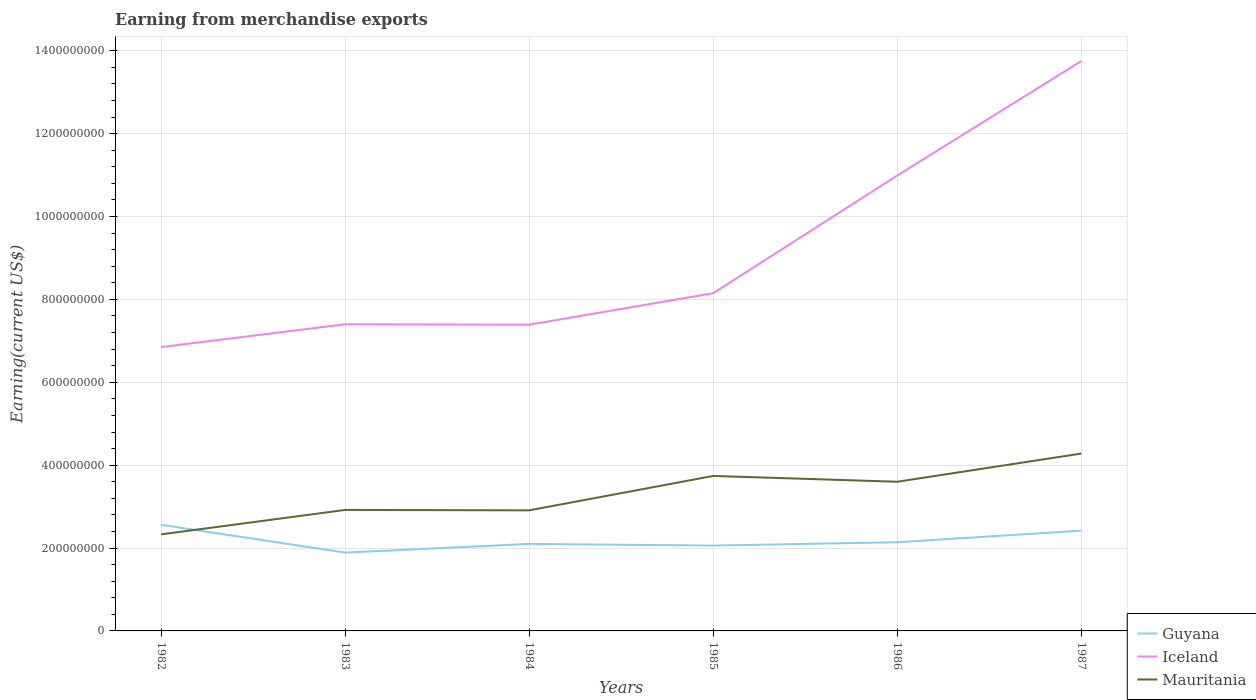Does the line corresponding to Mauritania intersect with the line corresponding to Guyana?
Your response must be concise. Yes. Is the number of lines equal to the number of legend labels?
Your response must be concise. Yes. Across all years, what is the maximum amount earned from merchandise exports in Guyana?
Your answer should be compact. 1.89e+08. In which year was the amount earned from merchandise exports in Iceland maximum?
Offer a terse response. 1982. What is the total amount earned from merchandise exports in Guyana in the graph?
Provide a short and direct response. -4.00e+06. What is the difference between the highest and the second highest amount earned from merchandise exports in Guyana?
Your response must be concise. 6.70e+07. What is the difference between the highest and the lowest amount earned from merchandise exports in Mauritania?
Your answer should be very brief. 3. How many lines are there?
Your response must be concise. 3. How many years are there in the graph?
Your answer should be very brief. 6. Are the values on the major ticks of Y-axis written in scientific E-notation?
Your answer should be compact. No. Does the graph contain any zero values?
Provide a short and direct response. No. Does the graph contain grids?
Offer a terse response. Yes. Where does the legend appear in the graph?
Give a very brief answer. Bottom right. What is the title of the graph?
Provide a succinct answer. Earning from merchandise exports. What is the label or title of the X-axis?
Give a very brief answer. Years. What is the label or title of the Y-axis?
Provide a short and direct response. Earning(current US$). What is the Earning(current US$) of Guyana in 1982?
Offer a terse response. 2.56e+08. What is the Earning(current US$) in Iceland in 1982?
Offer a very short reply. 6.85e+08. What is the Earning(current US$) in Mauritania in 1982?
Your answer should be compact. 2.33e+08. What is the Earning(current US$) in Guyana in 1983?
Keep it short and to the point. 1.89e+08. What is the Earning(current US$) of Iceland in 1983?
Ensure brevity in your answer.  7.40e+08. What is the Earning(current US$) in Mauritania in 1983?
Ensure brevity in your answer.  2.92e+08. What is the Earning(current US$) of Guyana in 1984?
Offer a terse response. 2.10e+08. What is the Earning(current US$) in Iceland in 1984?
Provide a succinct answer. 7.39e+08. What is the Earning(current US$) of Mauritania in 1984?
Offer a terse response. 2.91e+08. What is the Earning(current US$) in Guyana in 1985?
Offer a terse response. 2.06e+08. What is the Earning(current US$) in Iceland in 1985?
Provide a short and direct response. 8.15e+08. What is the Earning(current US$) in Mauritania in 1985?
Offer a terse response. 3.74e+08. What is the Earning(current US$) of Guyana in 1986?
Your response must be concise. 2.14e+08. What is the Earning(current US$) of Iceland in 1986?
Provide a succinct answer. 1.10e+09. What is the Earning(current US$) in Mauritania in 1986?
Provide a short and direct response. 3.60e+08. What is the Earning(current US$) in Guyana in 1987?
Offer a very short reply. 2.42e+08. What is the Earning(current US$) in Iceland in 1987?
Offer a very short reply. 1.38e+09. What is the Earning(current US$) in Mauritania in 1987?
Make the answer very short. 4.28e+08. Across all years, what is the maximum Earning(current US$) in Guyana?
Your response must be concise. 2.56e+08. Across all years, what is the maximum Earning(current US$) of Iceland?
Keep it short and to the point. 1.38e+09. Across all years, what is the maximum Earning(current US$) of Mauritania?
Your response must be concise. 4.28e+08. Across all years, what is the minimum Earning(current US$) of Guyana?
Offer a terse response. 1.89e+08. Across all years, what is the minimum Earning(current US$) of Iceland?
Make the answer very short. 6.85e+08. Across all years, what is the minimum Earning(current US$) in Mauritania?
Keep it short and to the point. 2.33e+08. What is the total Earning(current US$) in Guyana in the graph?
Ensure brevity in your answer.  1.32e+09. What is the total Earning(current US$) of Iceland in the graph?
Your answer should be very brief. 5.45e+09. What is the total Earning(current US$) of Mauritania in the graph?
Your answer should be very brief. 1.98e+09. What is the difference between the Earning(current US$) in Guyana in 1982 and that in 1983?
Your answer should be compact. 6.70e+07. What is the difference between the Earning(current US$) of Iceland in 1982 and that in 1983?
Make the answer very short. -5.50e+07. What is the difference between the Earning(current US$) of Mauritania in 1982 and that in 1983?
Offer a very short reply. -5.90e+07. What is the difference between the Earning(current US$) in Guyana in 1982 and that in 1984?
Provide a short and direct response. 4.60e+07. What is the difference between the Earning(current US$) in Iceland in 1982 and that in 1984?
Provide a short and direct response. -5.40e+07. What is the difference between the Earning(current US$) in Mauritania in 1982 and that in 1984?
Your response must be concise. -5.80e+07. What is the difference between the Earning(current US$) in Iceland in 1982 and that in 1985?
Offer a very short reply. -1.30e+08. What is the difference between the Earning(current US$) in Mauritania in 1982 and that in 1985?
Make the answer very short. -1.41e+08. What is the difference between the Earning(current US$) of Guyana in 1982 and that in 1986?
Give a very brief answer. 4.20e+07. What is the difference between the Earning(current US$) of Iceland in 1982 and that in 1986?
Make the answer very short. -4.14e+08. What is the difference between the Earning(current US$) in Mauritania in 1982 and that in 1986?
Your answer should be very brief. -1.27e+08. What is the difference between the Earning(current US$) in Guyana in 1982 and that in 1987?
Give a very brief answer. 1.40e+07. What is the difference between the Earning(current US$) in Iceland in 1982 and that in 1987?
Give a very brief answer. -6.90e+08. What is the difference between the Earning(current US$) in Mauritania in 1982 and that in 1987?
Ensure brevity in your answer.  -1.95e+08. What is the difference between the Earning(current US$) of Guyana in 1983 and that in 1984?
Your answer should be very brief. -2.10e+07. What is the difference between the Earning(current US$) of Mauritania in 1983 and that in 1984?
Make the answer very short. 1.00e+06. What is the difference between the Earning(current US$) in Guyana in 1983 and that in 1985?
Keep it short and to the point. -1.70e+07. What is the difference between the Earning(current US$) of Iceland in 1983 and that in 1985?
Your answer should be very brief. -7.50e+07. What is the difference between the Earning(current US$) of Mauritania in 1983 and that in 1985?
Your answer should be compact. -8.20e+07. What is the difference between the Earning(current US$) in Guyana in 1983 and that in 1986?
Offer a very short reply. -2.50e+07. What is the difference between the Earning(current US$) of Iceland in 1983 and that in 1986?
Make the answer very short. -3.59e+08. What is the difference between the Earning(current US$) of Mauritania in 1983 and that in 1986?
Your answer should be compact. -6.80e+07. What is the difference between the Earning(current US$) of Guyana in 1983 and that in 1987?
Your response must be concise. -5.30e+07. What is the difference between the Earning(current US$) in Iceland in 1983 and that in 1987?
Your answer should be compact. -6.35e+08. What is the difference between the Earning(current US$) in Mauritania in 1983 and that in 1987?
Offer a terse response. -1.36e+08. What is the difference between the Earning(current US$) of Iceland in 1984 and that in 1985?
Offer a terse response. -7.60e+07. What is the difference between the Earning(current US$) of Mauritania in 1984 and that in 1985?
Your answer should be compact. -8.30e+07. What is the difference between the Earning(current US$) in Iceland in 1984 and that in 1986?
Provide a succinct answer. -3.60e+08. What is the difference between the Earning(current US$) in Mauritania in 1984 and that in 1986?
Keep it short and to the point. -6.90e+07. What is the difference between the Earning(current US$) of Guyana in 1984 and that in 1987?
Your answer should be compact. -3.20e+07. What is the difference between the Earning(current US$) of Iceland in 1984 and that in 1987?
Make the answer very short. -6.36e+08. What is the difference between the Earning(current US$) of Mauritania in 1984 and that in 1987?
Your answer should be very brief. -1.37e+08. What is the difference between the Earning(current US$) in Guyana in 1985 and that in 1986?
Provide a succinct answer. -8.00e+06. What is the difference between the Earning(current US$) of Iceland in 1985 and that in 1986?
Your answer should be very brief. -2.84e+08. What is the difference between the Earning(current US$) in Mauritania in 1985 and that in 1986?
Keep it short and to the point. 1.40e+07. What is the difference between the Earning(current US$) of Guyana in 1985 and that in 1987?
Offer a very short reply. -3.60e+07. What is the difference between the Earning(current US$) in Iceland in 1985 and that in 1987?
Give a very brief answer. -5.60e+08. What is the difference between the Earning(current US$) of Mauritania in 1985 and that in 1987?
Your answer should be very brief. -5.40e+07. What is the difference between the Earning(current US$) of Guyana in 1986 and that in 1987?
Keep it short and to the point. -2.80e+07. What is the difference between the Earning(current US$) of Iceland in 1986 and that in 1987?
Give a very brief answer. -2.76e+08. What is the difference between the Earning(current US$) in Mauritania in 1986 and that in 1987?
Ensure brevity in your answer.  -6.80e+07. What is the difference between the Earning(current US$) of Guyana in 1982 and the Earning(current US$) of Iceland in 1983?
Keep it short and to the point. -4.84e+08. What is the difference between the Earning(current US$) in Guyana in 1982 and the Earning(current US$) in Mauritania in 1983?
Make the answer very short. -3.60e+07. What is the difference between the Earning(current US$) in Iceland in 1982 and the Earning(current US$) in Mauritania in 1983?
Give a very brief answer. 3.93e+08. What is the difference between the Earning(current US$) in Guyana in 1982 and the Earning(current US$) in Iceland in 1984?
Your answer should be very brief. -4.83e+08. What is the difference between the Earning(current US$) of Guyana in 1982 and the Earning(current US$) of Mauritania in 1984?
Keep it short and to the point. -3.50e+07. What is the difference between the Earning(current US$) in Iceland in 1982 and the Earning(current US$) in Mauritania in 1984?
Your response must be concise. 3.94e+08. What is the difference between the Earning(current US$) in Guyana in 1982 and the Earning(current US$) in Iceland in 1985?
Keep it short and to the point. -5.59e+08. What is the difference between the Earning(current US$) in Guyana in 1982 and the Earning(current US$) in Mauritania in 1985?
Make the answer very short. -1.18e+08. What is the difference between the Earning(current US$) in Iceland in 1982 and the Earning(current US$) in Mauritania in 1985?
Keep it short and to the point. 3.11e+08. What is the difference between the Earning(current US$) in Guyana in 1982 and the Earning(current US$) in Iceland in 1986?
Provide a short and direct response. -8.43e+08. What is the difference between the Earning(current US$) of Guyana in 1982 and the Earning(current US$) of Mauritania in 1986?
Make the answer very short. -1.04e+08. What is the difference between the Earning(current US$) in Iceland in 1982 and the Earning(current US$) in Mauritania in 1986?
Give a very brief answer. 3.25e+08. What is the difference between the Earning(current US$) of Guyana in 1982 and the Earning(current US$) of Iceland in 1987?
Provide a succinct answer. -1.12e+09. What is the difference between the Earning(current US$) in Guyana in 1982 and the Earning(current US$) in Mauritania in 1987?
Your response must be concise. -1.72e+08. What is the difference between the Earning(current US$) of Iceland in 1982 and the Earning(current US$) of Mauritania in 1987?
Your answer should be very brief. 2.57e+08. What is the difference between the Earning(current US$) in Guyana in 1983 and the Earning(current US$) in Iceland in 1984?
Offer a very short reply. -5.50e+08. What is the difference between the Earning(current US$) of Guyana in 1983 and the Earning(current US$) of Mauritania in 1984?
Your answer should be compact. -1.02e+08. What is the difference between the Earning(current US$) in Iceland in 1983 and the Earning(current US$) in Mauritania in 1984?
Provide a short and direct response. 4.49e+08. What is the difference between the Earning(current US$) of Guyana in 1983 and the Earning(current US$) of Iceland in 1985?
Provide a succinct answer. -6.26e+08. What is the difference between the Earning(current US$) of Guyana in 1983 and the Earning(current US$) of Mauritania in 1985?
Offer a very short reply. -1.85e+08. What is the difference between the Earning(current US$) in Iceland in 1983 and the Earning(current US$) in Mauritania in 1985?
Offer a terse response. 3.66e+08. What is the difference between the Earning(current US$) of Guyana in 1983 and the Earning(current US$) of Iceland in 1986?
Keep it short and to the point. -9.10e+08. What is the difference between the Earning(current US$) in Guyana in 1983 and the Earning(current US$) in Mauritania in 1986?
Your answer should be very brief. -1.71e+08. What is the difference between the Earning(current US$) of Iceland in 1983 and the Earning(current US$) of Mauritania in 1986?
Provide a succinct answer. 3.80e+08. What is the difference between the Earning(current US$) of Guyana in 1983 and the Earning(current US$) of Iceland in 1987?
Your answer should be very brief. -1.19e+09. What is the difference between the Earning(current US$) of Guyana in 1983 and the Earning(current US$) of Mauritania in 1987?
Your response must be concise. -2.39e+08. What is the difference between the Earning(current US$) of Iceland in 1983 and the Earning(current US$) of Mauritania in 1987?
Keep it short and to the point. 3.12e+08. What is the difference between the Earning(current US$) in Guyana in 1984 and the Earning(current US$) in Iceland in 1985?
Make the answer very short. -6.05e+08. What is the difference between the Earning(current US$) in Guyana in 1984 and the Earning(current US$) in Mauritania in 1985?
Give a very brief answer. -1.64e+08. What is the difference between the Earning(current US$) in Iceland in 1984 and the Earning(current US$) in Mauritania in 1985?
Offer a very short reply. 3.65e+08. What is the difference between the Earning(current US$) of Guyana in 1984 and the Earning(current US$) of Iceland in 1986?
Give a very brief answer. -8.89e+08. What is the difference between the Earning(current US$) in Guyana in 1984 and the Earning(current US$) in Mauritania in 1986?
Your answer should be compact. -1.50e+08. What is the difference between the Earning(current US$) of Iceland in 1984 and the Earning(current US$) of Mauritania in 1986?
Your answer should be very brief. 3.79e+08. What is the difference between the Earning(current US$) in Guyana in 1984 and the Earning(current US$) in Iceland in 1987?
Keep it short and to the point. -1.16e+09. What is the difference between the Earning(current US$) of Guyana in 1984 and the Earning(current US$) of Mauritania in 1987?
Ensure brevity in your answer.  -2.18e+08. What is the difference between the Earning(current US$) of Iceland in 1984 and the Earning(current US$) of Mauritania in 1987?
Offer a very short reply. 3.11e+08. What is the difference between the Earning(current US$) of Guyana in 1985 and the Earning(current US$) of Iceland in 1986?
Your response must be concise. -8.93e+08. What is the difference between the Earning(current US$) of Guyana in 1985 and the Earning(current US$) of Mauritania in 1986?
Offer a terse response. -1.54e+08. What is the difference between the Earning(current US$) in Iceland in 1985 and the Earning(current US$) in Mauritania in 1986?
Keep it short and to the point. 4.55e+08. What is the difference between the Earning(current US$) of Guyana in 1985 and the Earning(current US$) of Iceland in 1987?
Your answer should be very brief. -1.17e+09. What is the difference between the Earning(current US$) of Guyana in 1985 and the Earning(current US$) of Mauritania in 1987?
Your answer should be very brief. -2.22e+08. What is the difference between the Earning(current US$) of Iceland in 1985 and the Earning(current US$) of Mauritania in 1987?
Offer a very short reply. 3.87e+08. What is the difference between the Earning(current US$) of Guyana in 1986 and the Earning(current US$) of Iceland in 1987?
Make the answer very short. -1.16e+09. What is the difference between the Earning(current US$) in Guyana in 1986 and the Earning(current US$) in Mauritania in 1987?
Ensure brevity in your answer.  -2.14e+08. What is the difference between the Earning(current US$) of Iceland in 1986 and the Earning(current US$) of Mauritania in 1987?
Your response must be concise. 6.71e+08. What is the average Earning(current US$) in Guyana per year?
Provide a succinct answer. 2.20e+08. What is the average Earning(current US$) in Iceland per year?
Give a very brief answer. 9.09e+08. What is the average Earning(current US$) of Mauritania per year?
Your response must be concise. 3.30e+08. In the year 1982, what is the difference between the Earning(current US$) in Guyana and Earning(current US$) in Iceland?
Keep it short and to the point. -4.29e+08. In the year 1982, what is the difference between the Earning(current US$) in Guyana and Earning(current US$) in Mauritania?
Provide a succinct answer. 2.30e+07. In the year 1982, what is the difference between the Earning(current US$) in Iceland and Earning(current US$) in Mauritania?
Your answer should be compact. 4.52e+08. In the year 1983, what is the difference between the Earning(current US$) in Guyana and Earning(current US$) in Iceland?
Provide a short and direct response. -5.51e+08. In the year 1983, what is the difference between the Earning(current US$) of Guyana and Earning(current US$) of Mauritania?
Offer a terse response. -1.03e+08. In the year 1983, what is the difference between the Earning(current US$) of Iceland and Earning(current US$) of Mauritania?
Your response must be concise. 4.48e+08. In the year 1984, what is the difference between the Earning(current US$) in Guyana and Earning(current US$) in Iceland?
Provide a succinct answer. -5.29e+08. In the year 1984, what is the difference between the Earning(current US$) of Guyana and Earning(current US$) of Mauritania?
Make the answer very short. -8.10e+07. In the year 1984, what is the difference between the Earning(current US$) of Iceland and Earning(current US$) of Mauritania?
Your answer should be very brief. 4.48e+08. In the year 1985, what is the difference between the Earning(current US$) in Guyana and Earning(current US$) in Iceland?
Offer a very short reply. -6.09e+08. In the year 1985, what is the difference between the Earning(current US$) in Guyana and Earning(current US$) in Mauritania?
Offer a terse response. -1.68e+08. In the year 1985, what is the difference between the Earning(current US$) of Iceland and Earning(current US$) of Mauritania?
Your response must be concise. 4.41e+08. In the year 1986, what is the difference between the Earning(current US$) of Guyana and Earning(current US$) of Iceland?
Give a very brief answer. -8.85e+08. In the year 1986, what is the difference between the Earning(current US$) of Guyana and Earning(current US$) of Mauritania?
Your answer should be very brief. -1.46e+08. In the year 1986, what is the difference between the Earning(current US$) of Iceland and Earning(current US$) of Mauritania?
Provide a short and direct response. 7.39e+08. In the year 1987, what is the difference between the Earning(current US$) of Guyana and Earning(current US$) of Iceland?
Offer a terse response. -1.13e+09. In the year 1987, what is the difference between the Earning(current US$) in Guyana and Earning(current US$) in Mauritania?
Keep it short and to the point. -1.86e+08. In the year 1987, what is the difference between the Earning(current US$) in Iceland and Earning(current US$) in Mauritania?
Your response must be concise. 9.47e+08. What is the ratio of the Earning(current US$) of Guyana in 1982 to that in 1983?
Provide a short and direct response. 1.35. What is the ratio of the Earning(current US$) in Iceland in 1982 to that in 1983?
Keep it short and to the point. 0.93. What is the ratio of the Earning(current US$) in Mauritania in 1982 to that in 1983?
Your response must be concise. 0.8. What is the ratio of the Earning(current US$) in Guyana in 1982 to that in 1984?
Your answer should be compact. 1.22. What is the ratio of the Earning(current US$) of Iceland in 1982 to that in 1984?
Your answer should be compact. 0.93. What is the ratio of the Earning(current US$) in Mauritania in 1982 to that in 1984?
Offer a very short reply. 0.8. What is the ratio of the Earning(current US$) in Guyana in 1982 to that in 1985?
Make the answer very short. 1.24. What is the ratio of the Earning(current US$) of Iceland in 1982 to that in 1985?
Your response must be concise. 0.84. What is the ratio of the Earning(current US$) of Mauritania in 1982 to that in 1985?
Provide a succinct answer. 0.62. What is the ratio of the Earning(current US$) of Guyana in 1982 to that in 1986?
Offer a very short reply. 1.2. What is the ratio of the Earning(current US$) of Iceland in 1982 to that in 1986?
Your answer should be very brief. 0.62. What is the ratio of the Earning(current US$) in Mauritania in 1982 to that in 1986?
Give a very brief answer. 0.65. What is the ratio of the Earning(current US$) in Guyana in 1982 to that in 1987?
Offer a terse response. 1.06. What is the ratio of the Earning(current US$) in Iceland in 1982 to that in 1987?
Keep it short and to the point. 0.5. What is the ratio of the Earning(current US$) of Mauritania in 1982 to that in 1987?
Keep it short and to the point. 0.54. What is the ratio of the Earning(current US$) of Guyana in 1983 to that in 1984?
Keep it short and to the point. 0.9. What is the ratio of the Earning(current US$) in Iceland in 1983 to that in 1984?
Offer a very short reply. 1. What is the ratio of the Earning(current US$) of Guyana in 1983 to that in 1985?
Give a very brief answer. 0.92. What is the ratio of the Earning(current US$) of Iceland in 1983 to that in 1985?
Provide a succinct answer. 0.91. What is the ratio of the Earning(current US$) in Mauritania in 1983 to that in 1985?
Provide a short and direct response. 0.78. What is the ratio of the Earning(current US$) of Guyana in 1983 to that in 1986?
Provide a succinct answer. 0.88. What is the ratio of the Earning(current US$) of Iceland in 1983 to that in 1986?
Provide a short and direct response. 0.67. What is the ratio of the Earning(current US$) in Mauritania in 1983 to that in 1986?
Provide a short and direct response. 0.81. What is the ratio of the Earning(current US$) in Guyana in 1983 to that in 1987?
Offer a terse response. 0.78. What is the ratio of the Earning(current US$) of Iceland in 1983 to that in 1987?
Give a very brief answer. 0.54. What is the ratio of the Earning(current US$) in Mauritania in 1983 to that in 1987?
Offer a terse response. 0.68. What is the ratio of the Earning(current US$) in Guyana in 1984 to that in 1985?
Your answer should be compact. 1.02. What is the ratio of the Earning(current US$) of Iceland in 1984 to that in 1985?
Give a very brief answer. 0.91. What is the ratio of the Earning(current US$) in Mauritania in 1984 to that in 1985?
Give a very brief answer. 0.78. What is the ratio of the Earning(current US$) in Guyana in 1984 to that in 1986?
Give a very brief answer. 0.98. What is the ratio of the Earning(current US$) in Iceland in 1984 to that in 1986?
Offer a terse response. 0.67. What is the ratio of the Earning(current US$) of Mauritania in 1984 to that in 1986?
Give a very brief answer. 0.81. What is the ratio of the Earning(current US$) in Guyana in 1984 to that in 1987?
Offer a terse response. 0.87. What is the ratio of the Earning(current US$) of Iceland in 1984 to that in 1987?
Give a very brief answer. 0.54. What is the ratio of the Earning(current US$) of Mauritania in 1984 to that in 1987?
Offer a very short reply. 0.68. What is the ratio of the Earning(current US$) in Guyana in 1985 to that in 1986?
Your answer should be compact. 0.96. What is the ratio of the Earning(current US$) of Iceland in 1985 to that in 1986?
Your answer should be compact. 0.74. What is the ratio of the Earning(current US$) in Mauritania in 1985 to that in 1986?
Your response must be concise. 1.04. What is the ratio of the Earning(current US$) of Guyana in 1985 to that in 1987?
Your response must be concise. 0.85. What is the ratio of the Earning(current US$) of Iceland in 1985 to that in 1987?
Your answer should be very brief. 0.59. What is the ratio of the Earning(current US$) in Mauritania in 1985 to that in 1987?
Keep it short and to the point. 0.87. What is the ratio of the Earning(current US$) of Guyana in 1986 to that in 1987?
Give a very brief answer. 0.88. What is the ratio of the Earning(current US$) in Iceland in 1986 to that in 1987?
Your answer should be very brief. 0.8. What is the ratio of the Earning(current US$) in Mauritania in 1986 to that in 1987?
Provide a short and direct response. 0.84. What is the difference between the highest and the second highest Earning(current US$) in Guyana?
Offer a very short reply. 1.40e+07. What is the difference between the highest and the second highest Earning(current US$) of Iceland?
Your answer should be very brief. 2.76e+08. What is the difference between the highest and the second highest Earning(current US$) in Mauritania?
Keep it short and to the point. 5.40e+07. What is the difference between the highest and the lowest Earning(current US$) of Guyana?
Your response must be concise. 6.70e+07. What is the difference between the highest and the lowest Earning(current US$) in Iceland?
Provide a short and direct response. 6.90e+08. What is the difference between the highest and the lowest Earning(current US$) of Mauritania?
Give a very brief answer. 1.95e+08. 